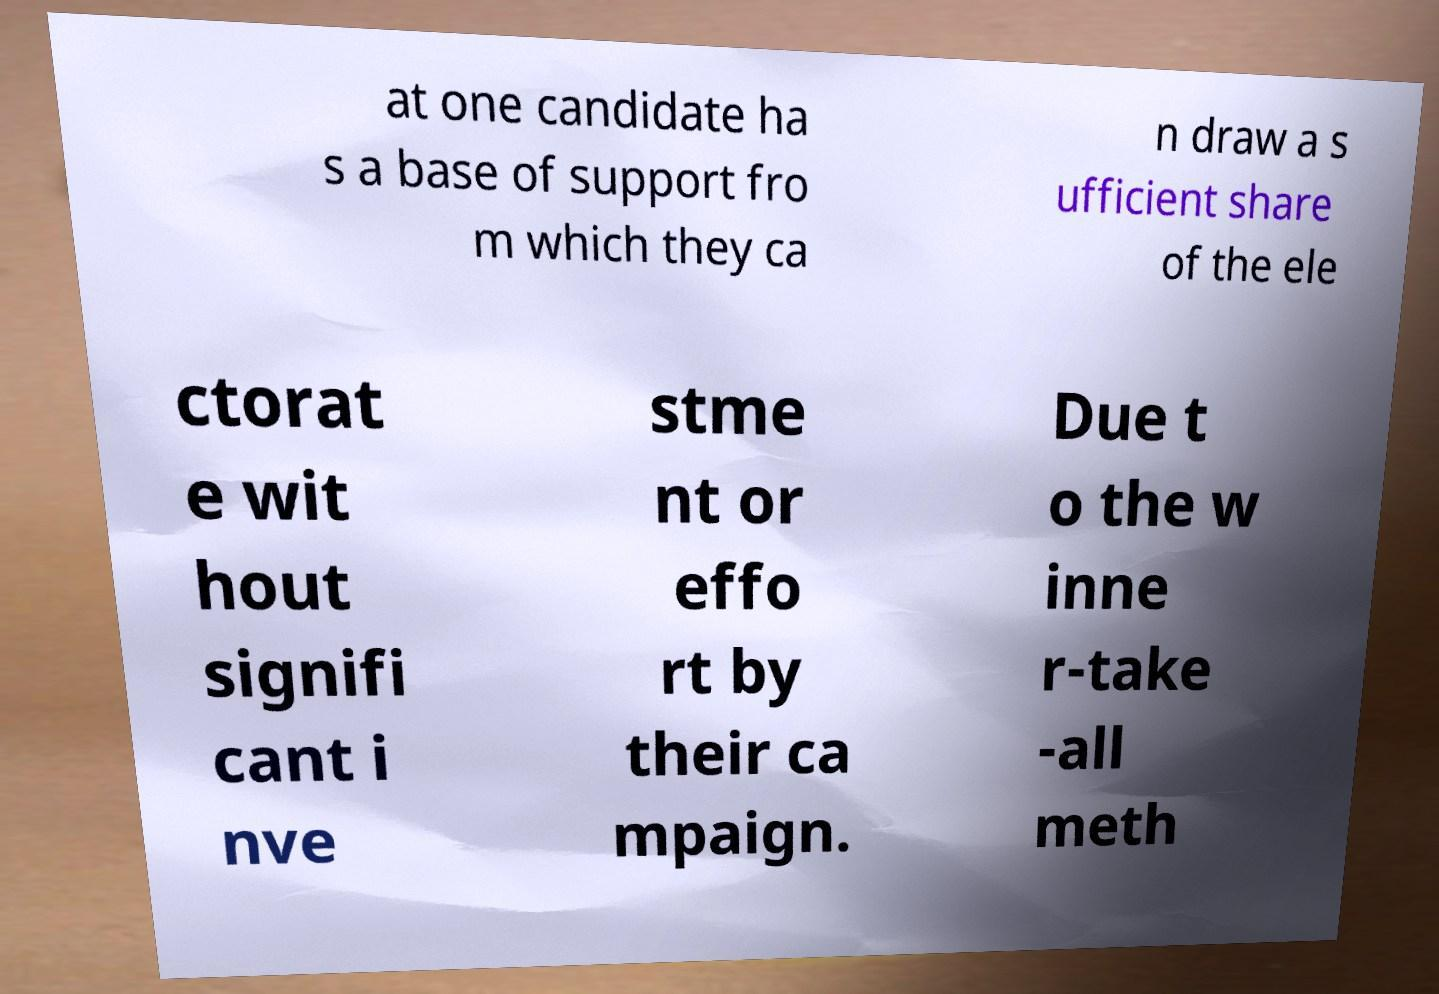Could you extract and type out the text from this image? at one candidate ha s a base of support fro m which they ca n draw a s ufficient share of the ele ctorat e wit hout signifi cant i nve stme nt or effo rt by their ca mpaign. Due t o the w inne r-take -all meth 